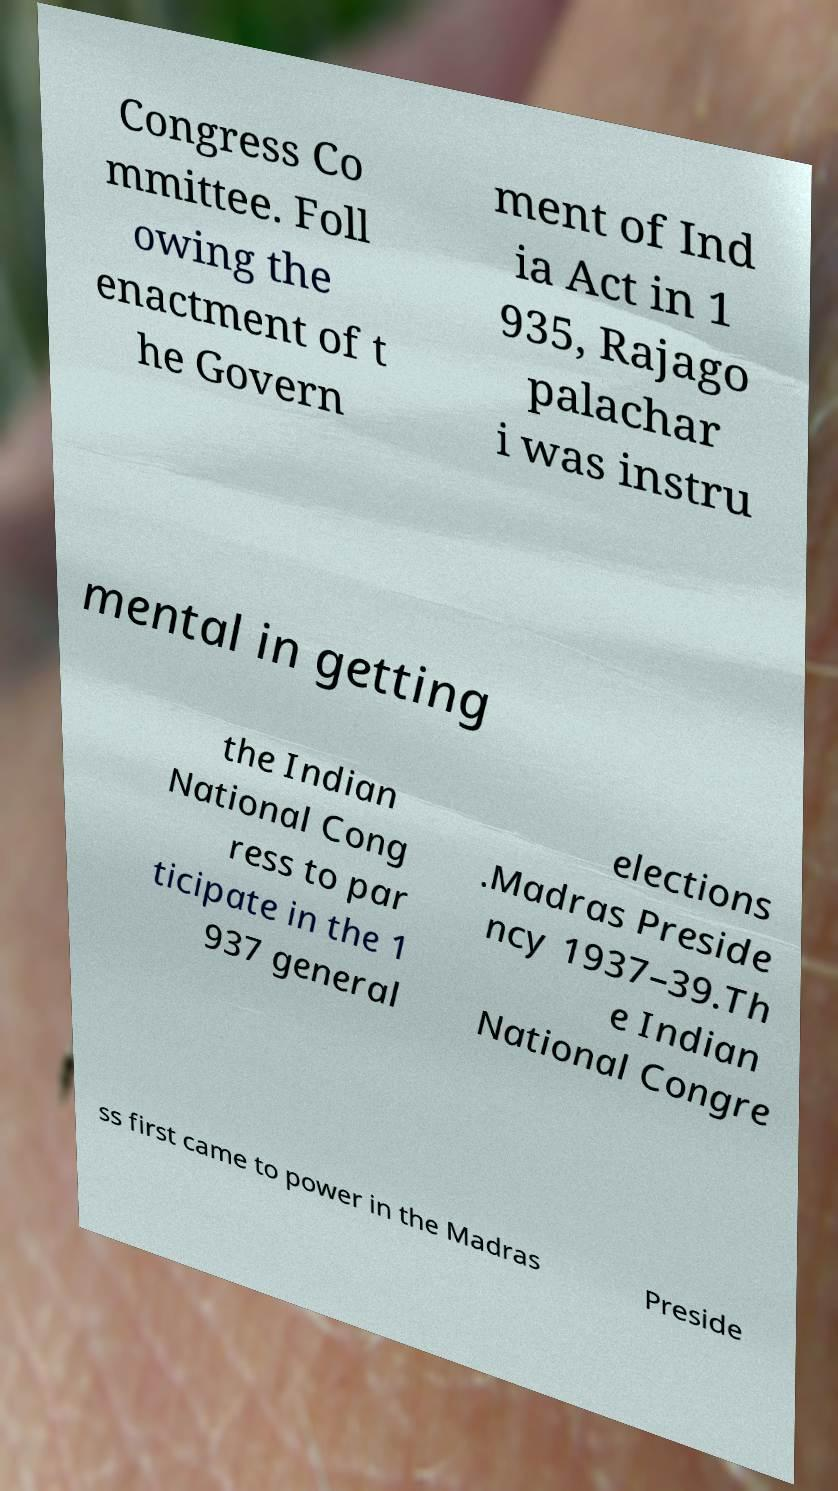Please read and relay the text visible in this image. What does it say? Congress Co mmittee. Foll owing the enactment of t he Govern ment of Ind ia Act in 1 935, Rajago palachar i was instru mental in getting the Indian National Cong ress to par ticipate in the 1 937 general elections .Madras Preside ncy 1937–39.Th e Indian National Congre ss first came to power in the Madras Preside 